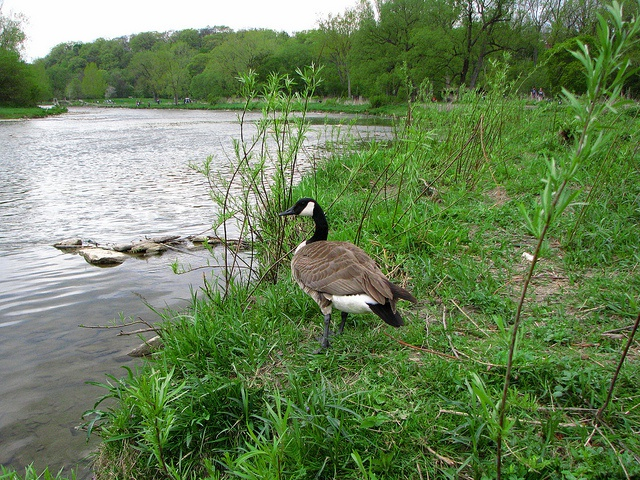Describe the objects in this image and their specific colors. I can see bird in lightblue, gray, black, and darkgray tones and bird in lightblue, white, darkgray, and gray tones in this image. 